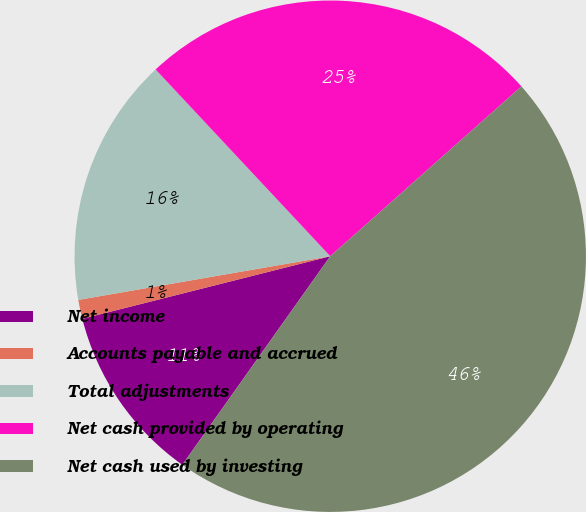Convert chart to OTSL. <chart><loc_0><loc_0><loc_500><loc_500><pie_chart><fcel>Net income<fcel>Accounts payable and accrued<fcel>Total adjustments<fcel>Net cash provided by operating<fcel>Net cash used by investing<nl><fcel>11.25%<fcel>1.2%<fcel>15.77%<fcel>25.41%<fcel>46.39%<nl></chart> 